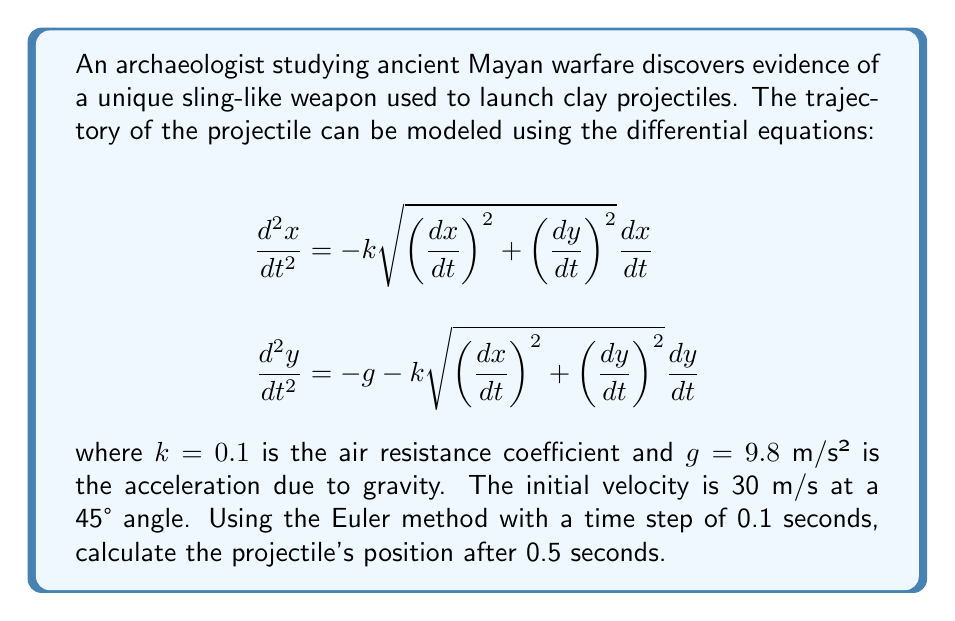What is the answer to this math problem? To solve this problem, we'll use the Euler method to numerically integrate the differential equations. Let's break it down step-by-step:

1) First, we need to set up our initial conditions:
   $x_0 = 0$, $y_0 = 0$
   $v_{x0} = 30 \cos(45°) = 21.21$ m/s
   $v_{y0} = 30 \sin(45°) = 21.21$ m/s

2) The Euler method for this system of equations is:
   $x_{n+1} = x_n + v_{xn} \Delta t$
   $y_{n+1} = y_n + v_{yn} \Delta t$
   $v_{xn+1} = v_{xn} - k\sqrt{v_{xn}^2 + v_{yn}^2}v_{xn} \Delta t$
   $v_{yn+1} = v_{yn} - (g + k\sqrt{v_{xn}^2 + v_{yn}^2}v_{yn}) \Delta t$

3) We'll use a time step $\Delta t = 0.1$ s and calculate for 5 steps to reach 0.5 seconds:

   Step 1 (t = 0.1 s):
   $x_1 = 0 + 21.21 * 0.1 = 2.121$ m
   $y_1 = 0 + 21.21 * 0.1 = 2.121$ m
   $v_{x1} = 21.21 - 0.1 * \sqrt{21.21^2 + 21.21^2} * 21.21 * 0.1 = 20.61$ m/s
   $v_{y1} = 21.21 - (9.8 + 0.1 * \sqrt{21.21^2 + 21.21^2} * 21.21) * 0.1 = 19.61$ m/s

   Step 2 (t = 0.2 s):
   $x_2 = 2.121 + 20.61 * 0.1 = 4.182$ m
   $y_2 = 2.121 + 19.61 * 0.1 = 4.082$ m
   $v_{x2} = 20.04$ m/s
   $v_{y2} = 18.06$ m/s

   Step 3 (t = 0.3 s):
   $x_3 = 6.186$ m
   $y_3 = 5.888$ m
   $v_{x3} = 19.50$ m/s
   $v_{y3} = 16.57$ m/s

   Step 4 (t = 0.4 s):
   $x_4 = 8.136$ m
   $y_4 = 7.545$ m
   $v_{x4} = 18.98$ m/s
   $v_{y4} = 15.14$ m/s

   Step 5 (t = 0.5 s):
   $x_5 = 10.034$ m
   $y_5 = 9.059$ m
   $v_{x5} = 18.49$ m/s
   $v_{y5} = 13.77$ m/s

4) Therefore, after 0.5 seconds, the projectile's position is approximately (10.034 m, 9.059 m).
Answer: (10.034 m, 9.059 m) 